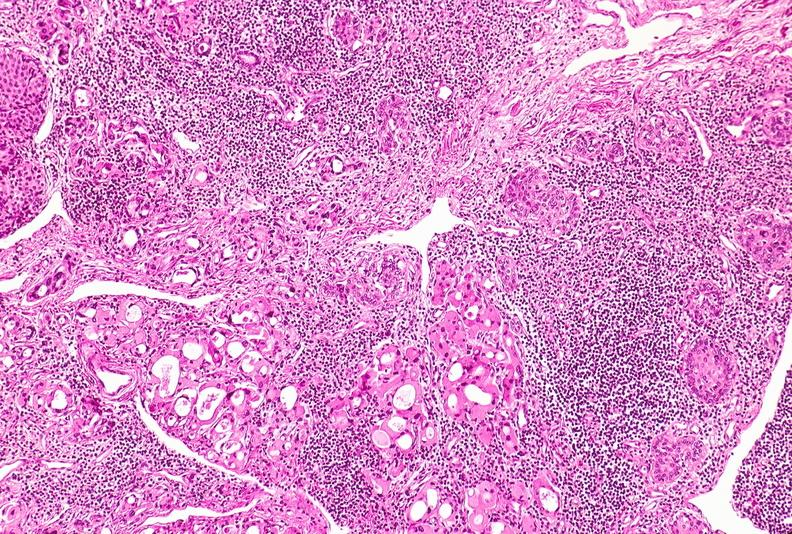what does this image show?
Answer the question using a single word or phrase. Thyroid 